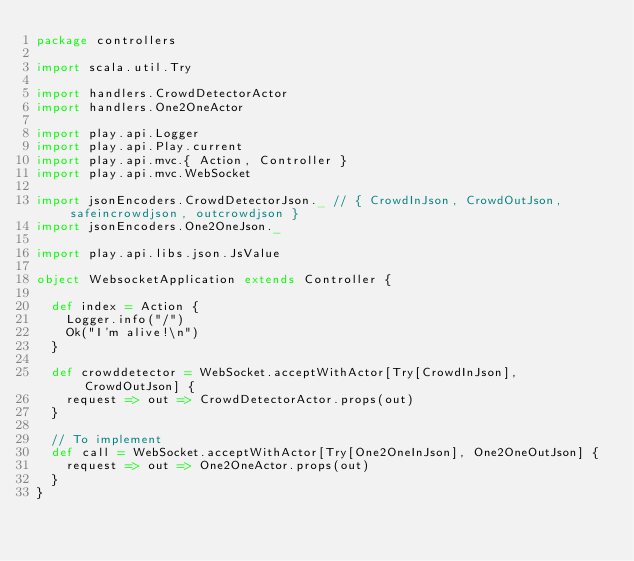Convert code to text. <code><loc_0><loc_0><loc_500><loc_500><_Scala_>package controllers

import scala.util.Try

import handlers.CrowdDetectorActor
import handlers.One2OneActor

import play.api.Logger
import play.api.Play.current
import play.api.mvc.{ Action, Controller }
import play.api.mvc.WebSocket

import jsonEncoders.CrowdDetectorJson._ // { CrowdInJson, CrowdOutJson, safeincrowdjson, outcrowdjson }
import jsonEncoders.One2OneJson._

import play.api.libs.json.JsValue

object WebsocketApplication extends Controller {

  def index = Action {
    Logger.info("/")
    Ok("I'm alive!\n")
  }

  def crowddetector = WebSocket.acceptWithActor[Try[CrowdInJson], CrowdOutJson] {
    request => out => CrowdDetectorActor.props(out)
  }

  // To implement
  def call = WebSocket.acceptWithActor[Try[One2OneInJson], One2OneOutJson] {
    request => out => One2OneActor.props(out)
  }
}</code> 